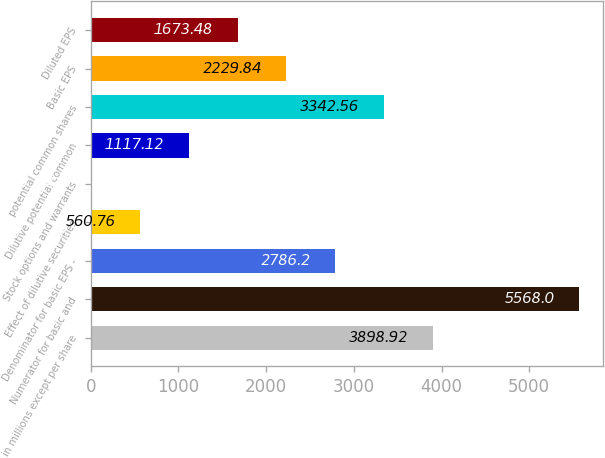Convert chart. <chart><loc_0><loc_0><loc_500><loc_500><bar_chart><fcel>in millions except per share<fcel>Numerator for basic and<fcel>Denominator for basic EPS -<fcel>Effect of dilutive securities<fcel>Stock options and warrants<fcel>Dilutive potential common<fcel>potential common shares<fcel>Basic EPS<fcel>Diluted EPS<nl><fcel>3898.92<fcel>5568<fcel>2786.2<fcel>560.76<fcel>4.4<fcel>1117.12<fcel>3342.56<fcel>2229.84<fcel>1673.48<nl></chart> 